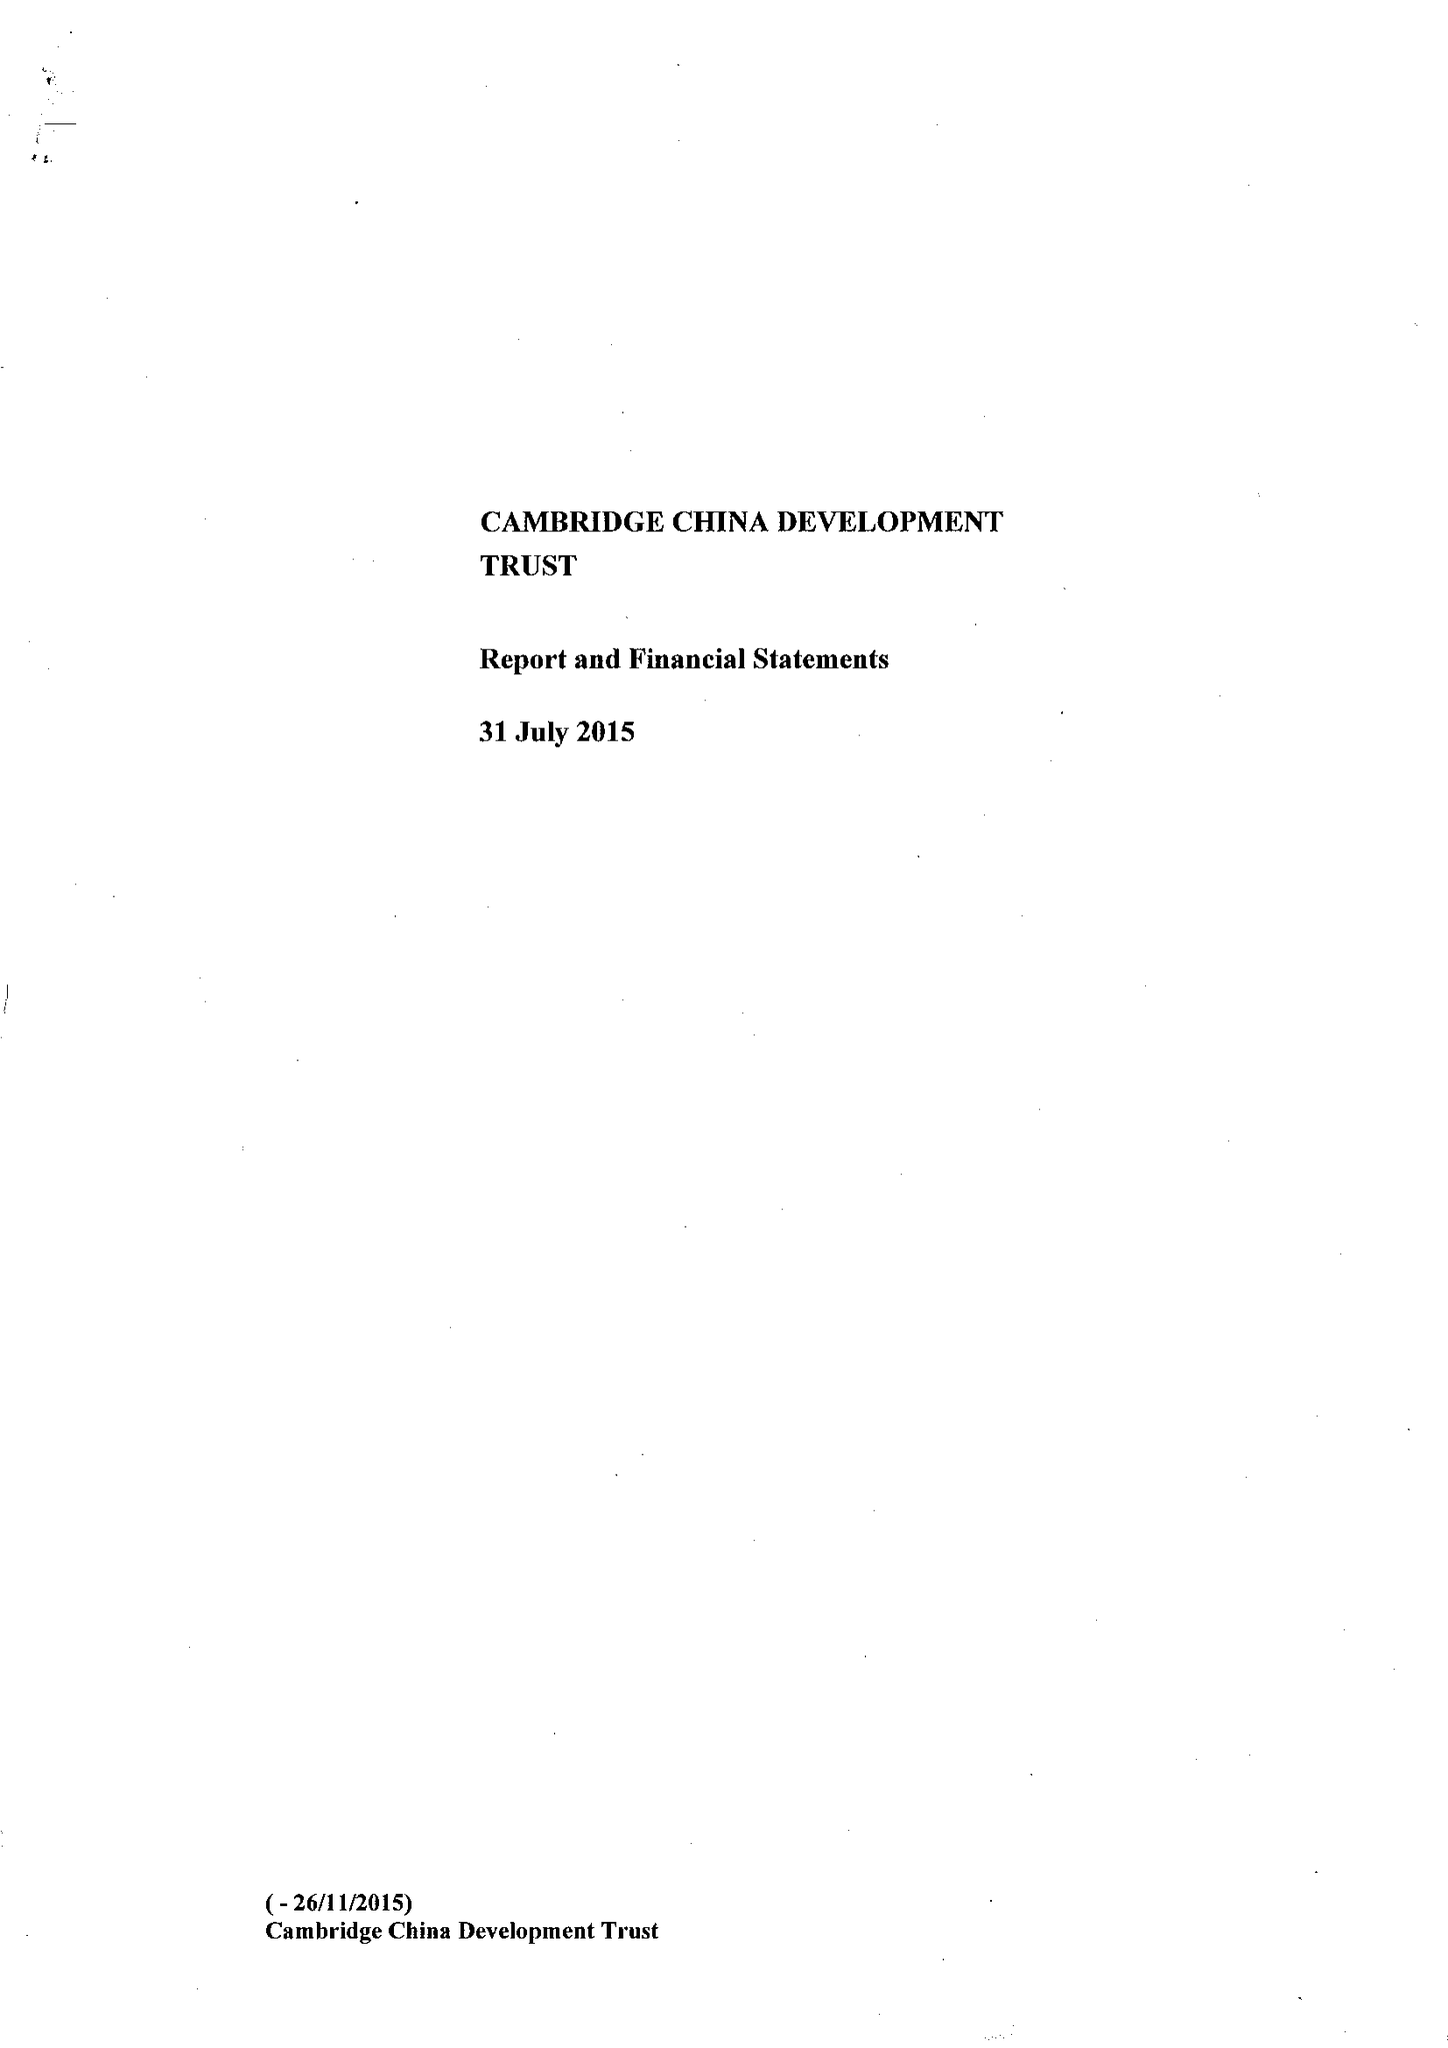What is the value for the report_date?
Answer the question using a single word or phrase. 2015-07-31 